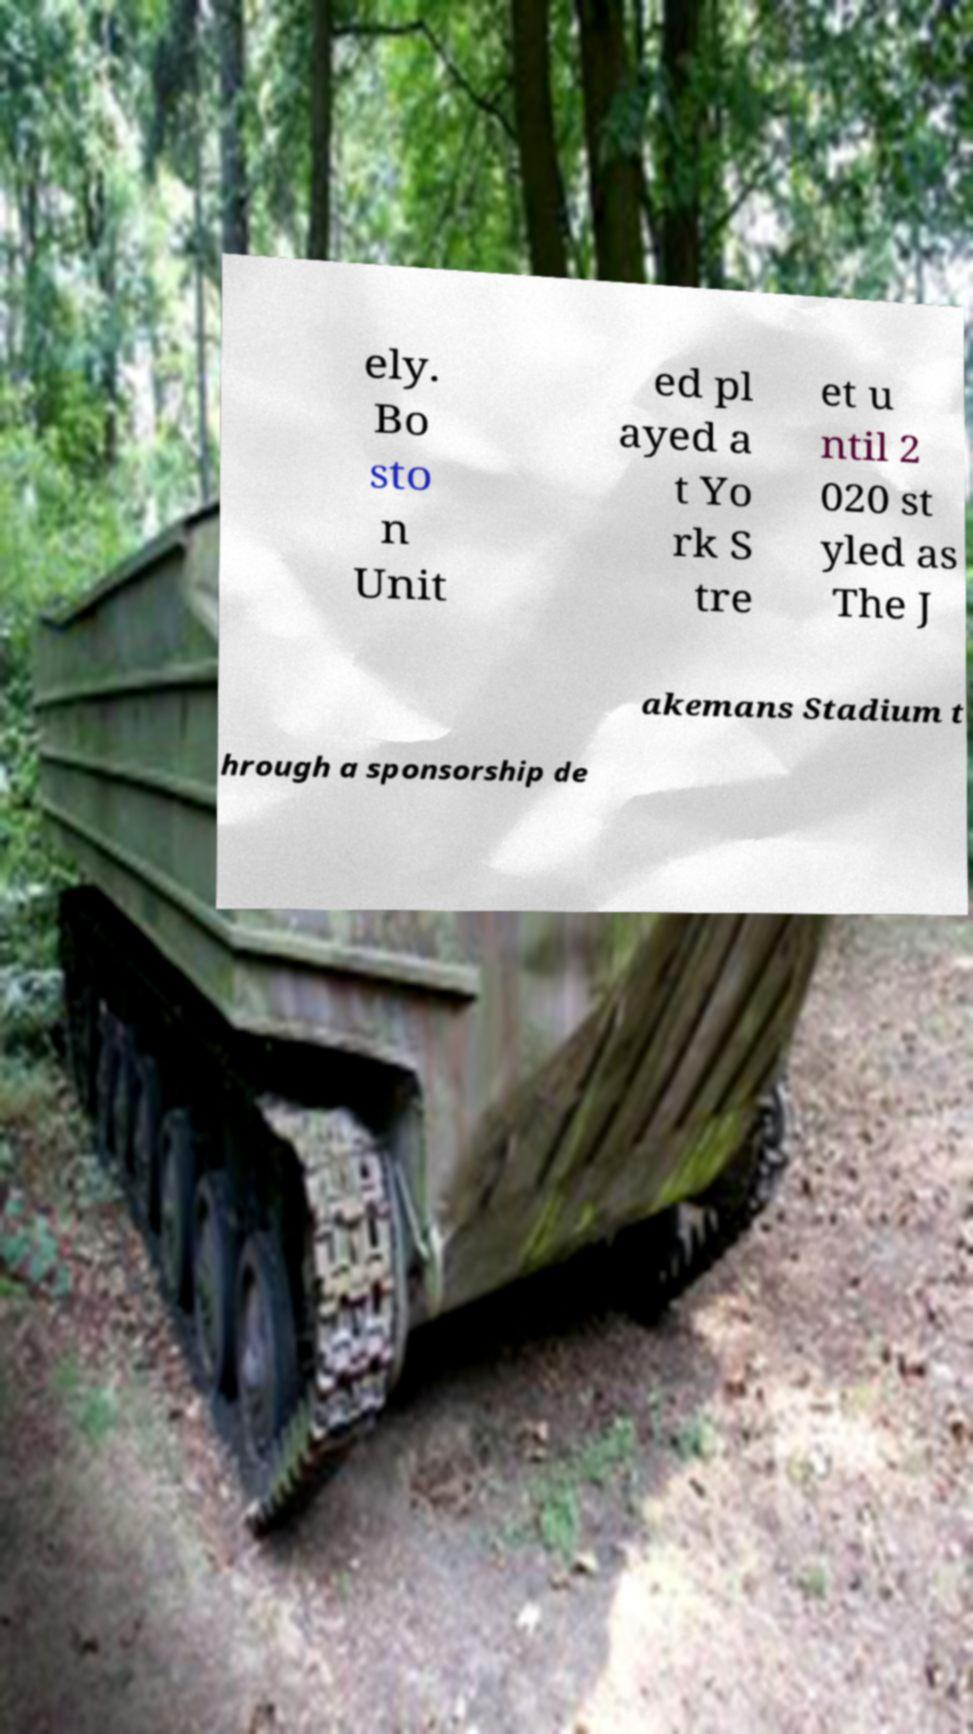Please read and relay the text visible in this image. What does it say? ely. Bo sto n Unit ed pl ayed a t Yo rk S tre et u ntil 2 020 st yled as The J akemans Stadium t hrough a sponsorship de 